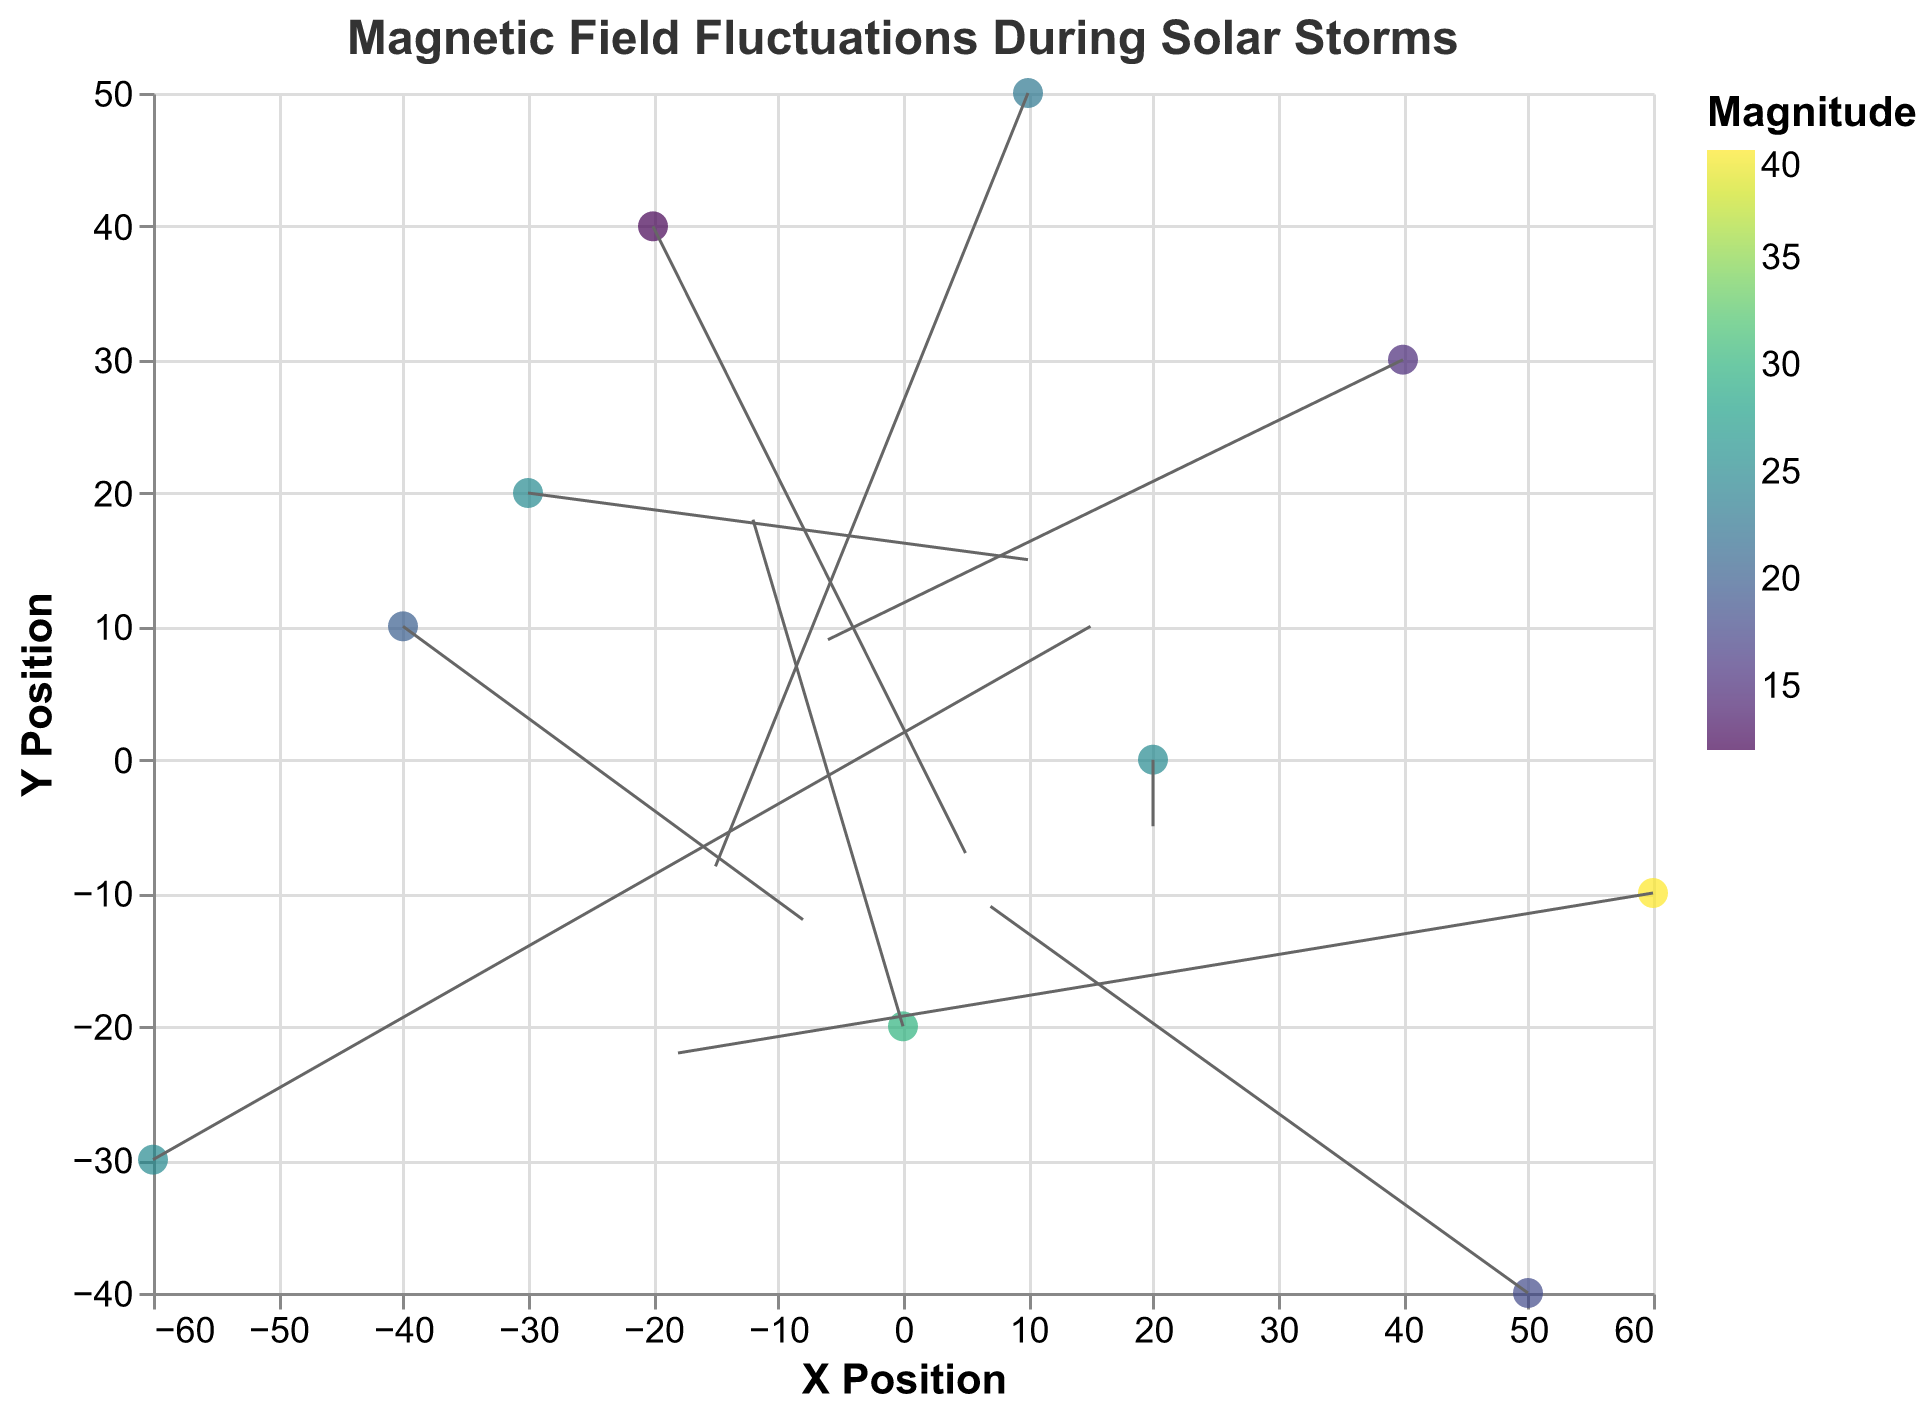What is the title of the plot? The title of the plot should be located at the top of the figure. It is usually in a prominent font and clearly describes the data visualized.
Answer: Magnetic Field Fluctuations During Solar Storms What are the labels of the x and y axes? The labels of the axes are typically located at the ends of the axes. They describe what the x and y values represent.
Answer: X Position, Y Position How many data points are represented in this plot? Each point on the plot corresponds to a data entry. Count the number of individual points shown in the figure to determine the total number of data points.
Answer: 10 Which satellite has the highest magnitude? The magnitude for each point can be obtained from the color legend. Identify the point with the highest magnitude value and look at its corresponding satellite name in the tooltip.
Answer: Intelsat 39 What is the direction and magnitude of the vector at position (0, -20)? Check the plot for the vector that originates from the coordinate (0, -20). The direction is given by the vector's arrow, and the magnitude can be added from the tooltip or inferred from the color.
Answer: Direction: (-12, 18), Magnitude: 30 Which satellite shows a vector with the highest negative U value? U value represents the x-component of the vector. Identify the vector with the most negative U value and look up its corresponding satellite name in the tooltip.
Answer: Intelsat 39 What is the average magnitude of all the vectors? To find the average magnitude, sum the magnitudes of all vectors and divide by the total number of vectors. Sum: (25 + 20 + 12 + 30 + 25 + 15 + 40 + 25 + 23 + 18) = 233. Number of vectors: 10. Divide the sum by the number of vectors: 233/10.
Answer: 23.3 Which satellite vector is closest to the origin (0,0)? Calculate the distance from the origin (0,0) for each vector. Use the distance formula √(X^2 + Y^2) for each point and identify the smallest distance.
Answer: Telstar 19 VANTAGE at (20,0) What is the net vector direction and magnitude at the coordinate (50,-40)? Find the vector originating from the coordinates (50,-40). The direction can be described by its U and V components, and the magnitude can be found in the tooltip.
Answer: Direction: (7, -11), Magnitude: 18 How many vectors have a positive U component? Count the number of vectors where the U component (x-direction) is greater than zero by checking each vector's information.
Answer: 4 vectors 